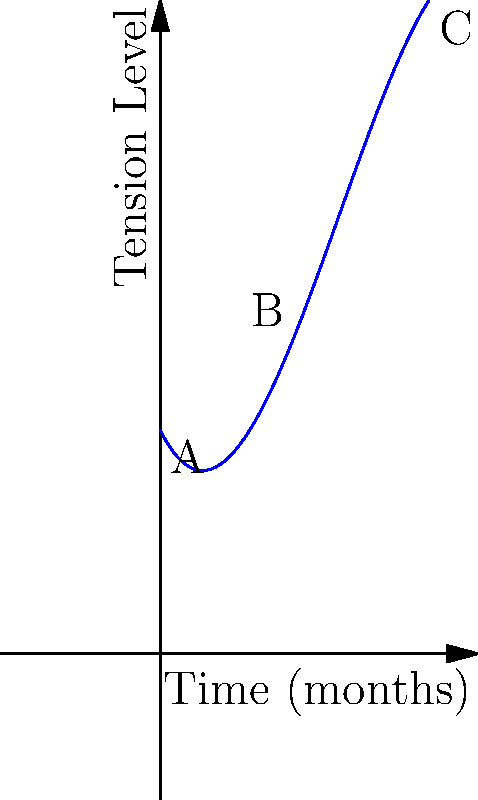Consider the polynomial function $f(x) = -0.1x^3 + 1.2x^2 - 2x + 5$ representing the tension level in a diplomatic crisis over time (in months). Based on the graph, at which point does the crisis reach its peak intensity, and what does this imply about the diplomatic situation? To answer this question, we need to analyze the graph and understand its implications:

1. The function $f(x)$ represents the tension level of a diplomatic crisis over time.

2. The x-axis represents time in months, while the y-axis represents the tension level.

3. We can see that the graph starts at point A (0 months), rises to a peak at point B, and then descends to point C (6 months).

4. The peak of the crisis occurs at point B, which is the highest point on the curve.

5. To find the coordinates of point B, we need to identify the vertex of the parabola-like section of the curve. Visually, this appears to be around the 3-month mark.

6. The fact that the curve peaks and then descends implies that the crisis intensifies for about 3 months and then begins to de-escalate.

7. This pattern suggests a typical diplomatic crisis lifecycle: escalation, peak, and de-escalation.

8. The gradual rise and fall of the curve indicate that diplomatic efforts might have been successful in managing the crisis after its peak intensity.

Therefore, the crisis reaches its peak intensity at approximately the 3-month mark (point B), implying that diplomatic tensions were highest at this point before diplomatic efforts likely helped to reduce the conflict.
Answer: Peak at 3 months; indicates maximum tension before successful de-escalation efforts. 